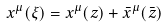Convert formula to latex. <formula><loc_0><loc_0><loc_500><loc_500>x ^ { \mu } ( \xi ) = x ^ { \mu } ( z ) + \bar { x } ^ { \mu } ( { \bar { z } } )</formula> 